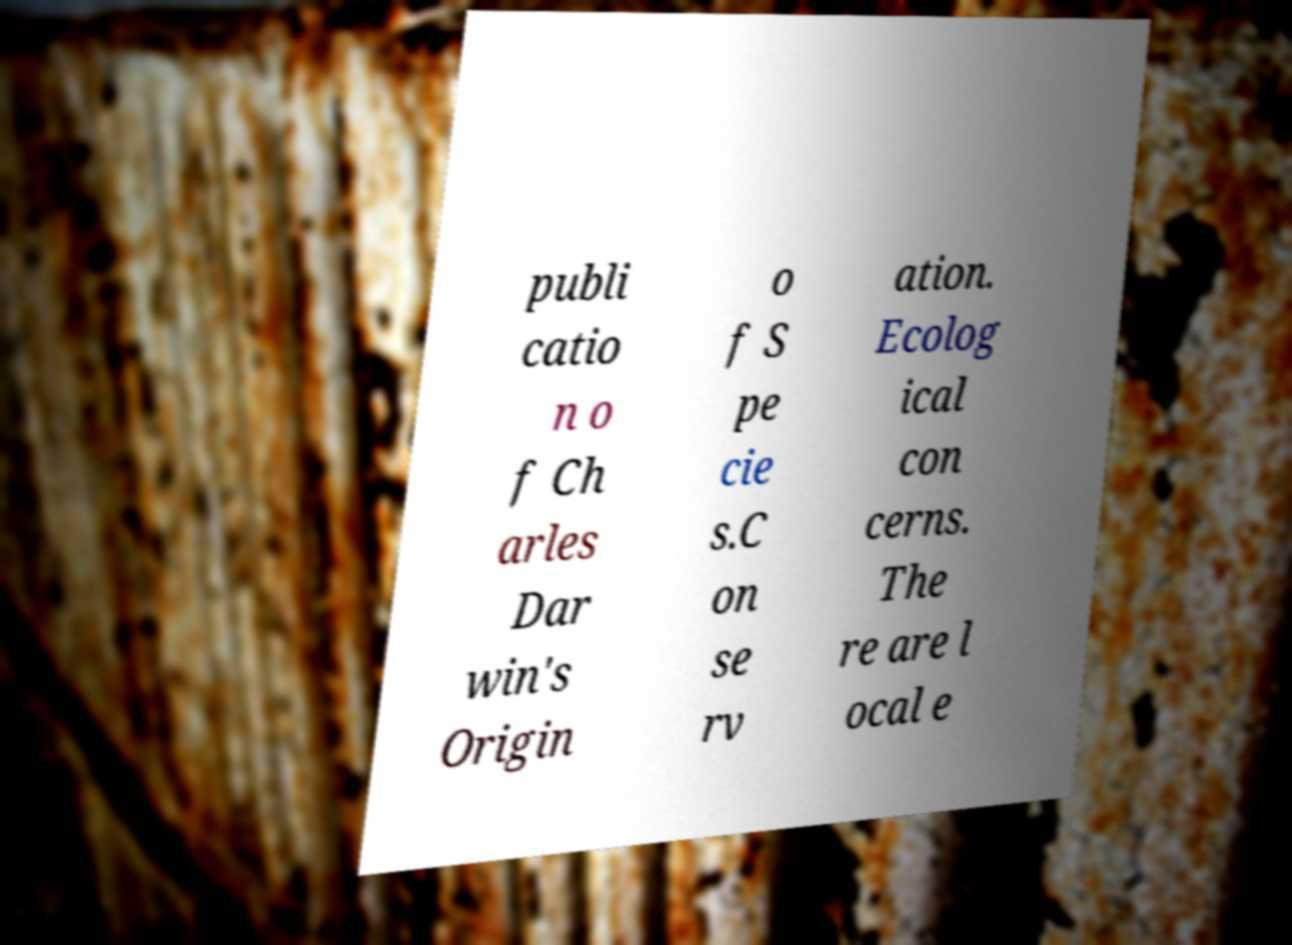I need the written content from this picture converted into text. Can you do that? publi catio n o f Ch arles Dar win's Origin o f S pe cie s.C on se rv ation. Ecolog ical con cerns. The re are l ocal e 